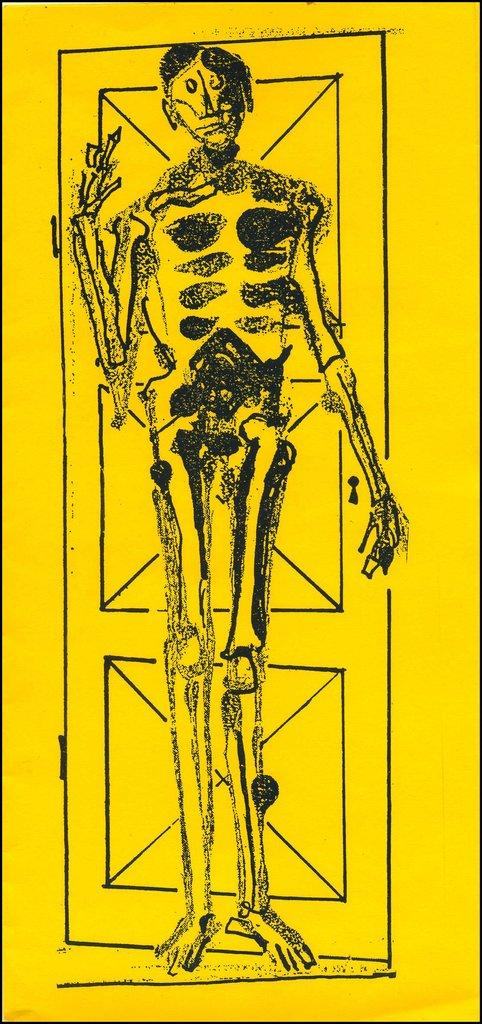What is present in the image that contains visual content? There is a poster in the image. What can be found on the poster? The poster contains images. What religious symbols can be seen on the poster in the image? There is no information about religious symbols on the poster in the image. What type of bird is depicted on the poster in the image? There is no information about a bird, specifically a turkey, on the poster in the image. 